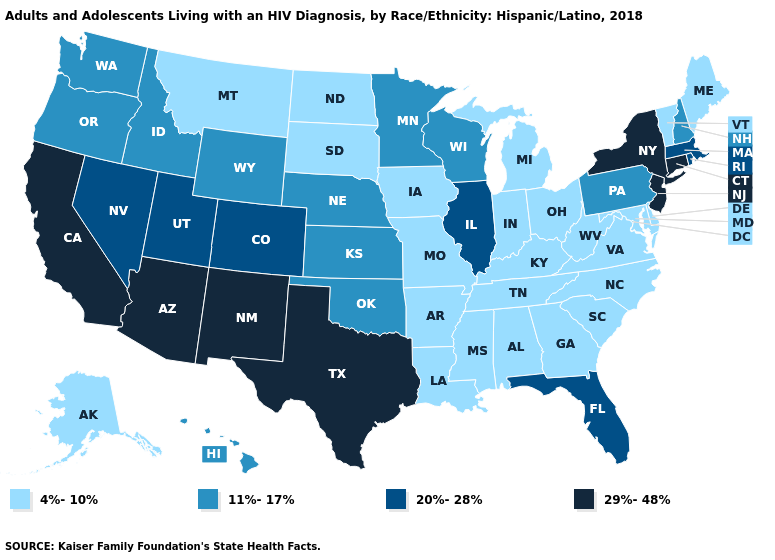Does North Carolina have the highest value in the USA?
Give a very brief answer. No. Which states hav the highest value in the West?
Short answer required. Arizona, California, New Mexico. Name the states that have a value in the range 4%-10%?
Answer briefly. Alabama, Alaska, Arkansas, Delaware, Georgia, Indiana, Iowa, Kentucky, Louisiana, Maine, Maryland, Michigan, Mississippi, Missouri, Montana, North Carolina, North Dakota, Ohio, South Carolina, South Dakota, Tennessee, Vermont, Virginia, West Virginia. What is the highest value in states that border Rhode Island?
Answer briefly. 29%-48%. Does New Jersey have the lowest value in the USA?
Quick response, please. No. Which states hav the highest value in the South?
Keep it brief. Texas. Name the states that have a value in the range 4%-10%?
Keep it brief. Alabama, Alaska, Arkansas, Delaware, Georgia, Indiana, Iowa, Kentucky, Louisiana, Maine, Maryland, Michigan, Mississippi, Missouri, Montana, North Carolina, North Dakota, Ohio, South Carolina, South Dakota, Tennessee, Vermont, Virginia, West Virginia. What is the value of Nebraska?
Give a very brief answer. 11%-17%. What is the value of Colorado?
Keep it brief. 20%-28%. Is the legend a continuous bar?
Concise answer only. No. Among the states that border Georgia , does Florida have the highest value?
Quick response, please. Yes. What is the value of Alaska?
Answer briefly. 4%-10%. What is the highest value in the West ?
Write a very short answer. 29%-48%. Does Ohio have the same value as New Mexico?
Give a very brief answer. No. 